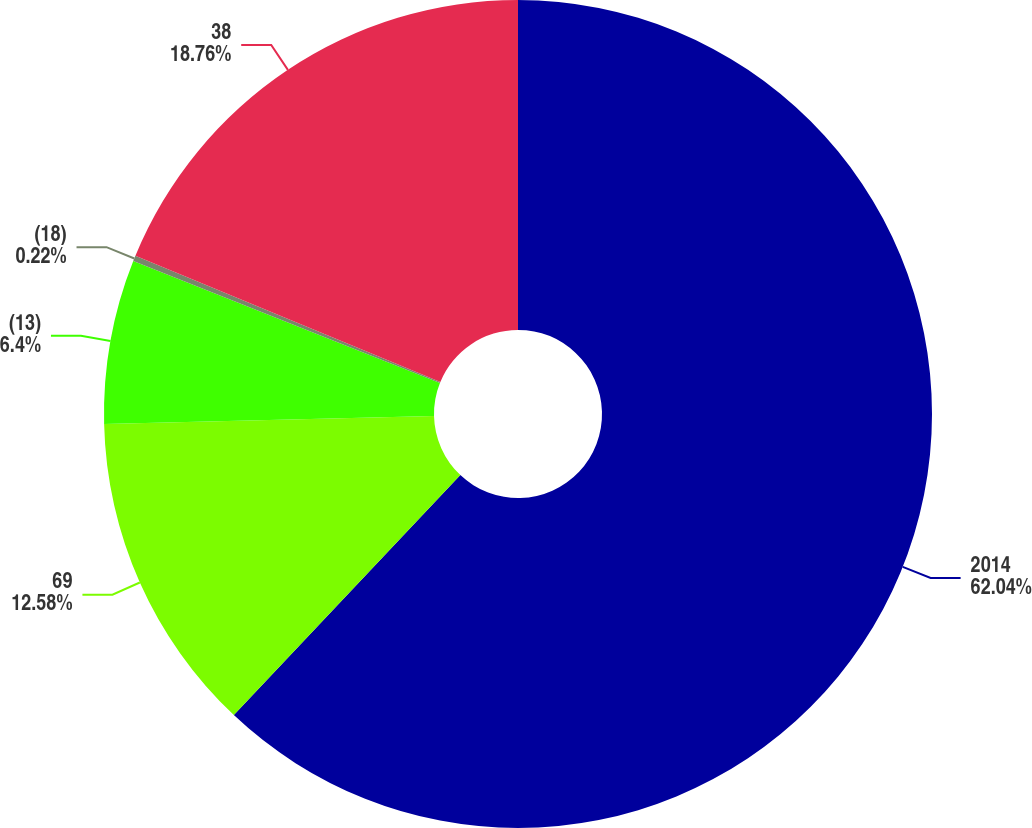Convert chart. <chart><loc_0><loc_0><loc_500><loc_500><pie_chart><fcel>2014<fcel>69<fcel>(13)<fcel>(18)<fcel>38<nl><fcel>62.04%<fcel>12.58%<fcel>6.4%<fcel>0.22%<fcel>18.76%<nl></chart> 